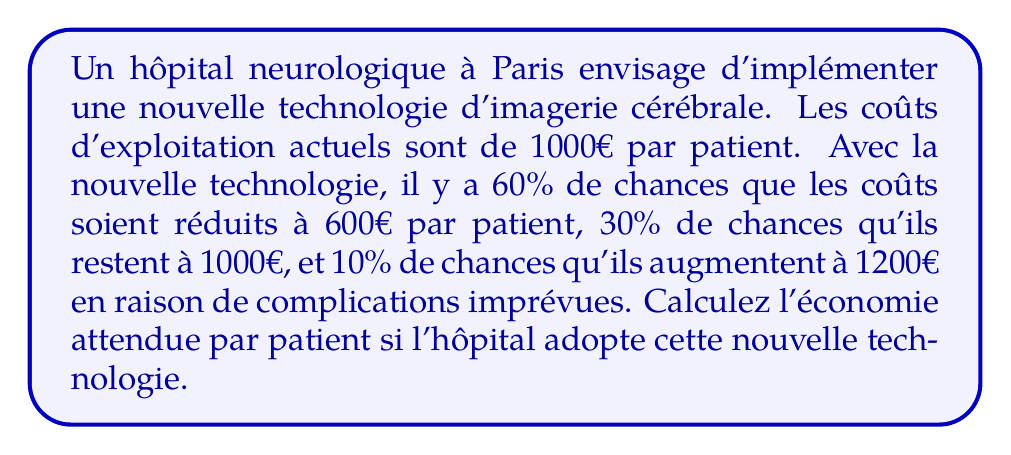What is the answer to this math problem? Pour résoudre ce problème, nous allons utiliser le concept de l'espérance mathématique. Voici les étapes :

1) Définissons les événements possibles et leurs probabilités :
   - A : Coûts réduits à 600€ (P(A) = 0,60)
   - B : Coûts inchangés à 1000€ (P(B) = 0,30)
   - C : Coûts augmentés à 1200€ (P(C) = 0,10)

2) Calculons le coût moyen attendu avec la nouvelle technologie :
   $$E(\text{nouveau coût}) = 600 \cdot 0,60 + 1000 \cdot 0,30 + 1200 \cdot 0,10$$
   $$E(\text{nouveau coût}) = 360 + 300 + 120 = 780€$$

3) Calculons l'économie attendue par patient :
   $$E(\text{économie}) = \text{Coût actuel} - E(\text{nouveau coût})$$
   $$E(\text{économie}) = 1000 - 780 = 220€$$

Donc, l'économie attendue par patient est de 220€.
Answer: 220€ 